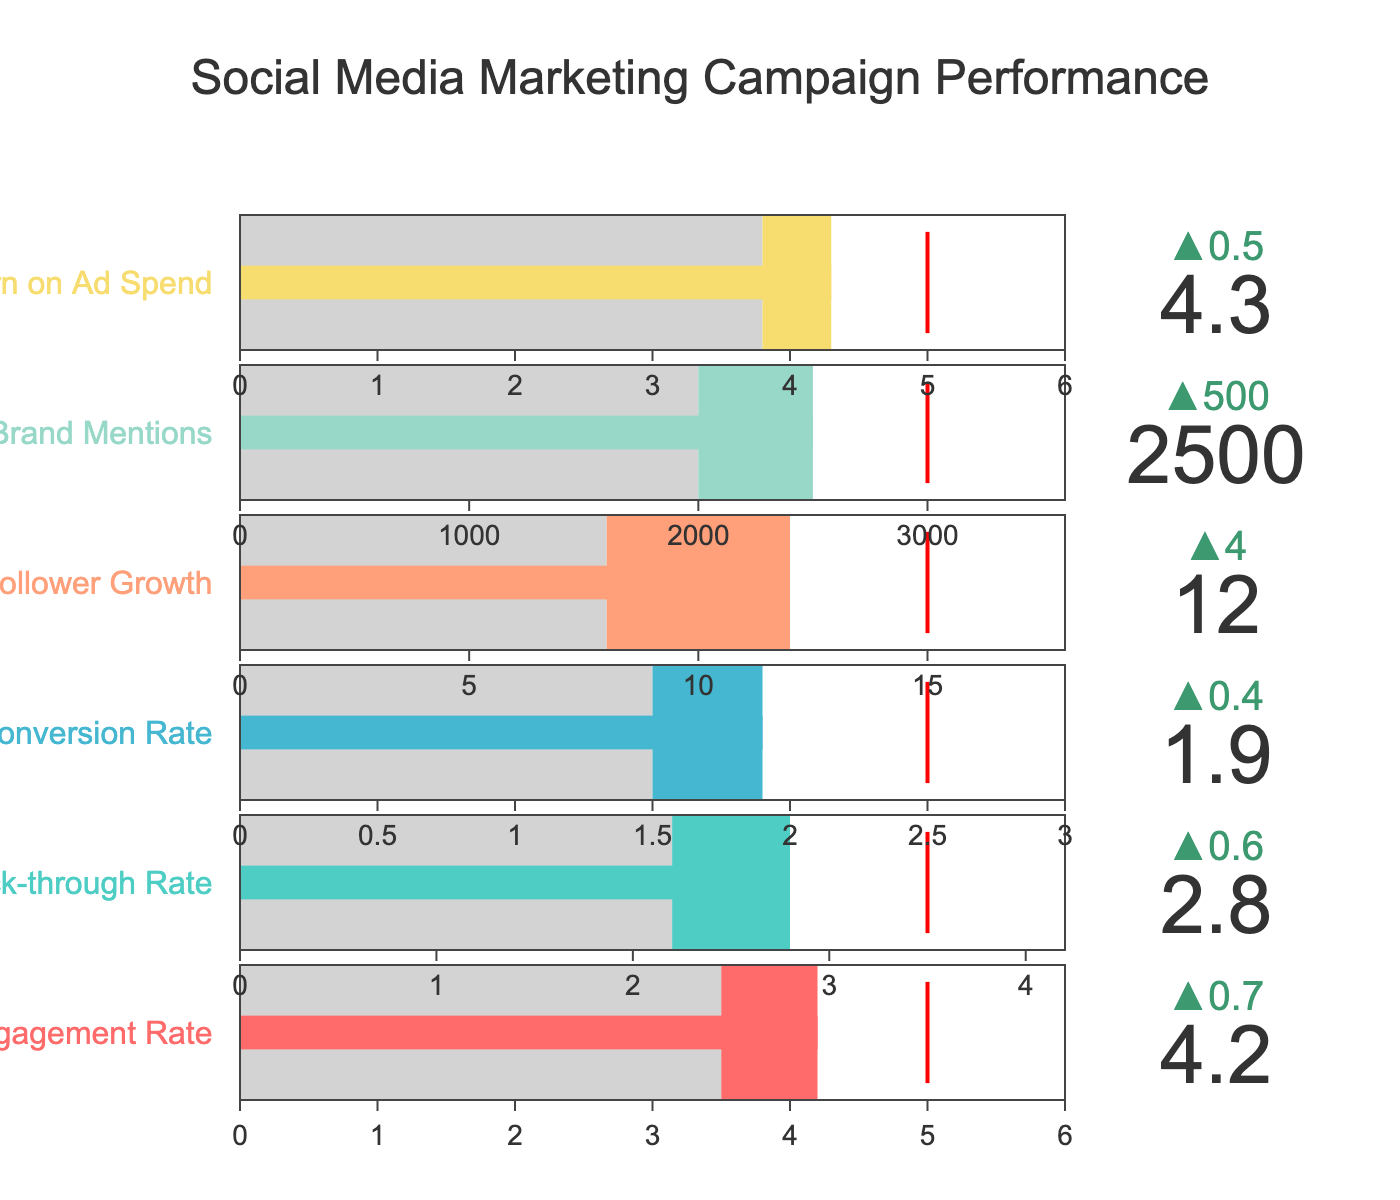What's the title of the figure? The title of the figure is often placed at the top of a chart, providing a summary of what the figure represents. By looking at the top of the figure, we can see the text displayed as the title.
Answer: Social Media Marketing Campaign Performance How many categories are shown in the figure? By counting the number of bullet charts or rows present in the figure, we can determine the number of categories displayed. Each category is labeled with a different performance metric.
Answer: 6 What is the actual performance for the 'Conversion Rate' category? The actual performance is the value displayed prominently on each bullet chart. For the 'Conversion Rate' category, locate the corresponding bullet chart and read the actual performance value indicated.
Answer: 1.9 How does the 'Engagement Rate' compare to its benchmark? To determine this, first find the actual performance and benchmark values for the 'Engagement Rate'. Compare these values to see if the actual performance is higher, lower, or equal to the benchmark.
Answer: Higher Which category has the highest target value? To find this, review the target values for each category by looking at the threshold lines in the bullet charts. Identify the category with the highest target value.
Answer: Brand Mentions Is any category's actual performance less than its benchmark? Check each bullet chart to compare the actual performance against the benchmark for all categories. If the actual performance is less than the benchmark in any category, that category meets the criteria.
Answer: No What is the difference between the actual performance and target for the 'Follower Growth' category? To calculate this, subtract the actual performance value from the target value for the 'Follower Growth' category.
Answer: 3 Which category has the highest return on ad spend? Find the category labeled 'Return on Ad Spend' and note its actual performance. Compare this value to other categories if needed, but for this specific metric, only one category is relevant.
Answer: Return on Ad Spend What steps does the bullet gauge in the 'Click-through Rate' category contain? Look at the individual bullet chart for 'Click-through Rate'. Each bullet gauge will have steps depicted in distinct colors. Identify the number and color of these steps.
Answer: Two steps: light gray and one colored step 